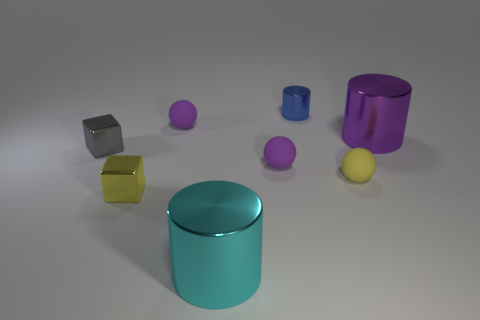What number of tiny blue metallic things are in front of the metal block behind the yellow block? 0 